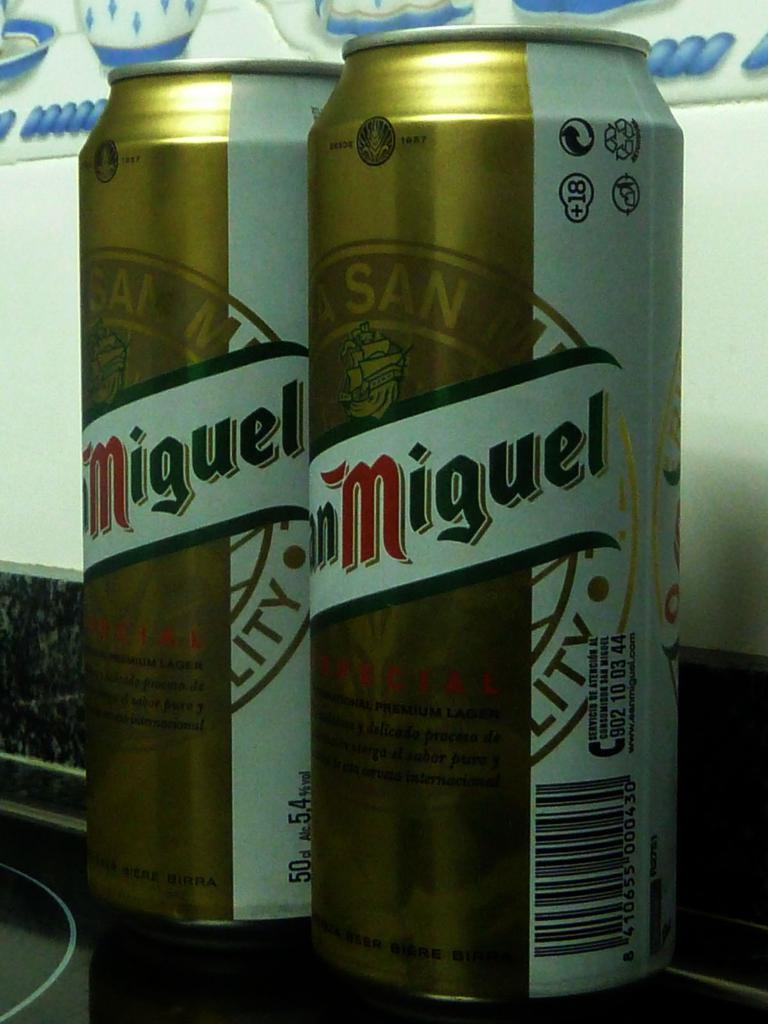<image>
Share a concise interpretation of the image provided. two cans of Miguel sit on the back of a stovetop 